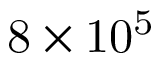<formula> <loc_0><loc_0><loc_500><loc_500>8 \times 1 0 ^ { 5 }</formula> 